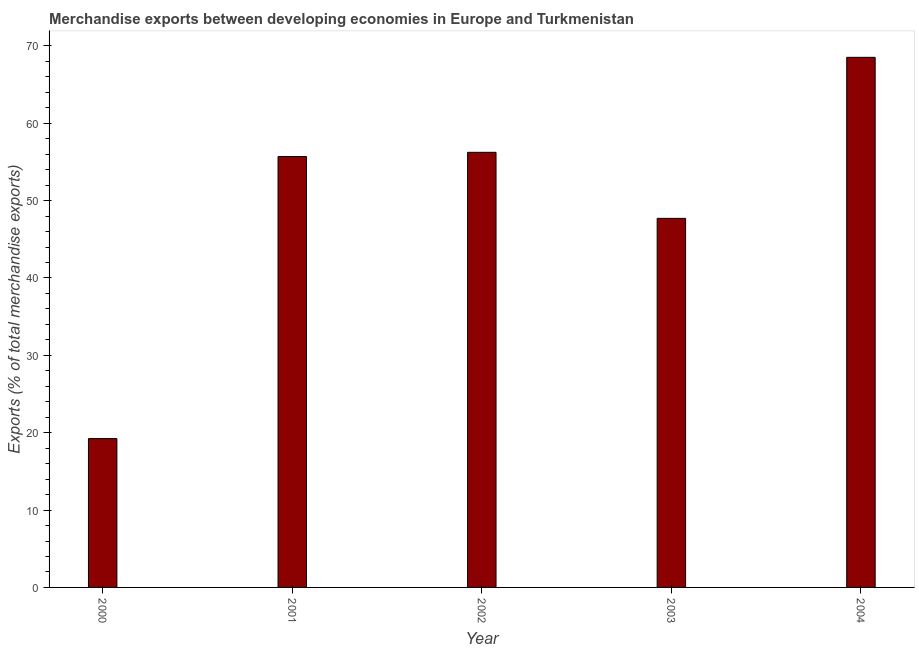What is the title of the graph?
Provide a short and direct response. Merchandise exports between developing economies in Europe and Turkmenistan. What is the label or title of the X-axis?
Your response must be concise. Year. What is the label or title of the Y-axis?
Offer a very short reply. Exports (% of total merchandise exports). What is the merchandise exports in 2001?
Your answer should be very brief. 55.69. Across all years, what is the maximum merchandise exports?
Your answer should be very brief. 68.52. Across all years, what is the minimum merchandise exports?
Keep it short and to the point. 19.24. In which year was the merchandise exports maximum?
Provide a succinct answer. 2004. In which year was the merchandise exports minimum?
Offer a very short reply. 2000. What is the sum of the merchandise exports?
Ensure brevity in your answer.  247.39. What is the difference between the merchandise exports in 2000 and 2004?
Ensure brevity in your answer.  -49.28. What is the average merchandise exports per year?
Offer a very short reply. 49.48. What is the median merchandise exports?
Ensure brevity in your answer.  55.69. Do a majority of the years between 2003 and 2001 (inclusive) have merchandise exports greater than 10 %?
Give a very brief answer. Yes. What is the ratio of the merchandise exports in 2000 to that in 2003?
Your answer should be compact. 0.4. Is the difference between the merchandise exports in 2000 and 2004 greater than the difference between any two years?
Your response must be concise. Yes. What is the difference between the highest and the second highest merchandise exports?
Your answer should be compact. 12.28. What is the difference between the highest and the lowest merchandise exports?
Offer a terse response. 49.28. How many bars are there?
Provide a succinct answer. 5. Are all the bars in the graph horizontal?
Your answer should be very brief. No. How many years are there in the graph?
Ensure brevity in your answer.  5. What is the difference between two consecutive major ticks on the Y-axis?
Offer a terse response. 10. Are the values on the major ticks of Y-axis written in scientific E-notation?
Offer a very short reply. No. What is the Exports (% of total merchandise exports) of 2000?
Ensure brevity in your answer.  19.24. What is the Exports (% of total merchandise exports) of 2001?
Make the answer very short. 55.69. What is the Exports (% of total merchandise exports) in 2002?
Provide a succinct answer. 56.24. What is the Exports (% of total merchandise exports) of 2003?
Your response must be concise. 47.7. What is the Exports (% of total merchandise exports) in 2004?
Keep it short and to the point. 68.52. What is the difference between the Exports (% of total merchandise exports) in 2000 and 2001?
Your response must be concise. -36.45. What is the difference between the Exports (% of total merchandise exports) in 2000 and 2002?
Your answer should be compact. -37. What is the difference between the Exports (% of total merchandise exports) in 2000 and 2003?
Your answer should be very brief. -28.46. What is the difference between the Exports (% of total merchandise exports) in 2000 and 2004?
Your answer should be very brief. -49.28. What is the difference between the Exports (% of total merchandise exports) in 2001 and 2002?
Make the answer very short. -0.54. What is the difference between the Exports (% of total merchandise exports) in 2001 and 2003?
Provide a succinct answer. 7.99. What is the difference between the Exports (% of total merchandise exports) in 2001 and 2004?
Your answer should be very brief. -12.82. What is the difference between the Exports (% of total merchandise exports) in 2002 and 2003?
Your answer should be compact. 8.54. What is the difference between the Exports (% of total merchandise exports) in 2002 and 2004?
Provide a succinct answer. -12.28. What is the difference between the Exports (% of total merchandise exports) in 2003 and 2004?
Offer a very short reply. -20.81. What is the ratio of the Exports (% of total merchandise exports) in 2000 to that in 2001?
Your answer should be very brief. 0.34. What is the ratio of the Exports (% of total merchandise exports) in 2000 to that in 2002?
Offer a very short reply. 0.34. What is the ratio of the Exports (% of total merchandise exports) in 2000 to that in 2003?
Provide a succinct answer. 0.4. What is the ratio of the Exports (% of total merchandise exports) in 2000 to that in 2004?
Give a very brief answer. 0.28. What is the ratio of the Exports (% of total merchandise exports) in 2001 to that in 2003?
Your response must be concise. 1.17. What is the ratio of the Exports (% of total merchandise exports) in 2001 to that in 2004?
Offer a terse response. 0.81. What is the ratio of the Exports (% of total merchandise exports) in 2002 to that in 2003?
Give a very brief answer. 1.18. What is the ratio of the Exports (% of total merchandise exports) in 2002 to that in 2004?
Ensure brevity in your answer.  0.82. What is the ratio of the Exports (% of total merchandise exports) in 2003 to that in 2004?
Ensure brevity in your answer.  0.7. 